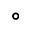<formula> <loc_0><loc_0><loc_500><loc_500>^ { \circ }</formula> 